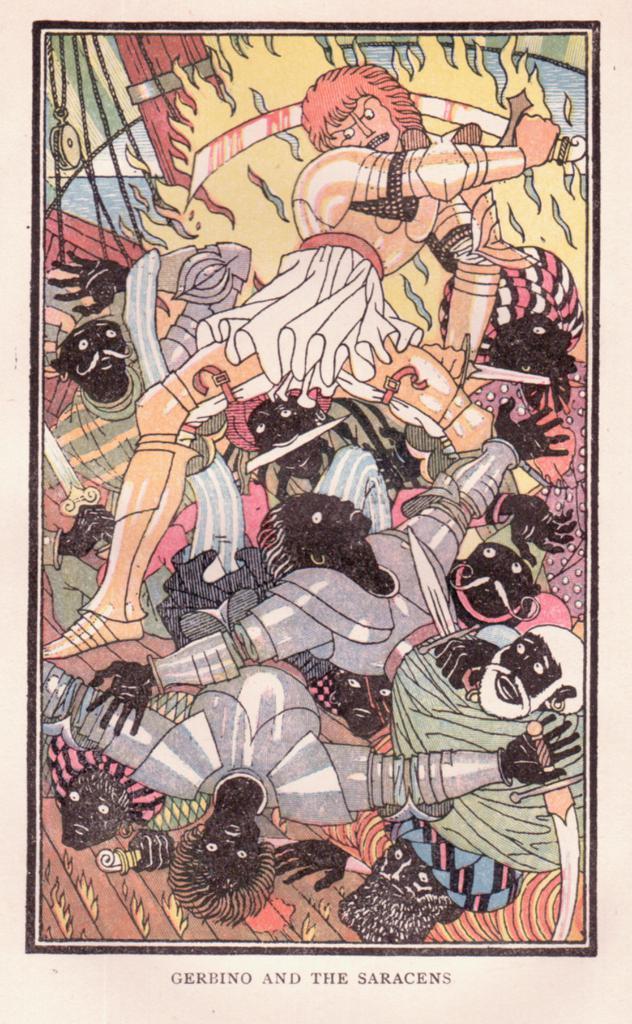Please provide a concise description of this image. In this image I can see few cartoon pictures and the pictures are in multi color and I can see something is written on the image. 